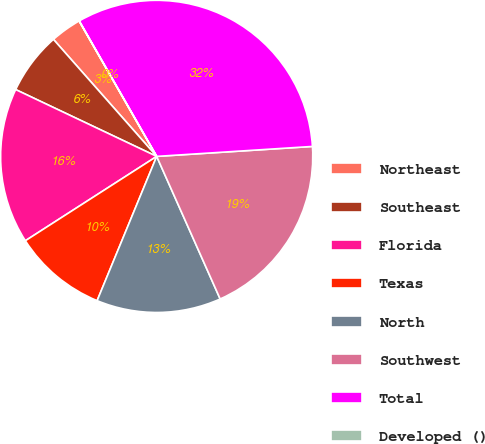Convert chart. <chart><loc_0><loc_0><loc_500><loc_500><pie_chart><fcel>Northeast<fcel>Southeast<fcel>Florida<fcel>Texas<fcel>North<fcel>Southwest<fcel>Total<fcel>Developed ()<nl><fcel>3.23%<fcel>6.45%<fcel>16.13%<fcel>9.68%<fcel>12.9%<fcel>19.35%<fcel>32.25%<fcel>0.01%<nl></chart> 